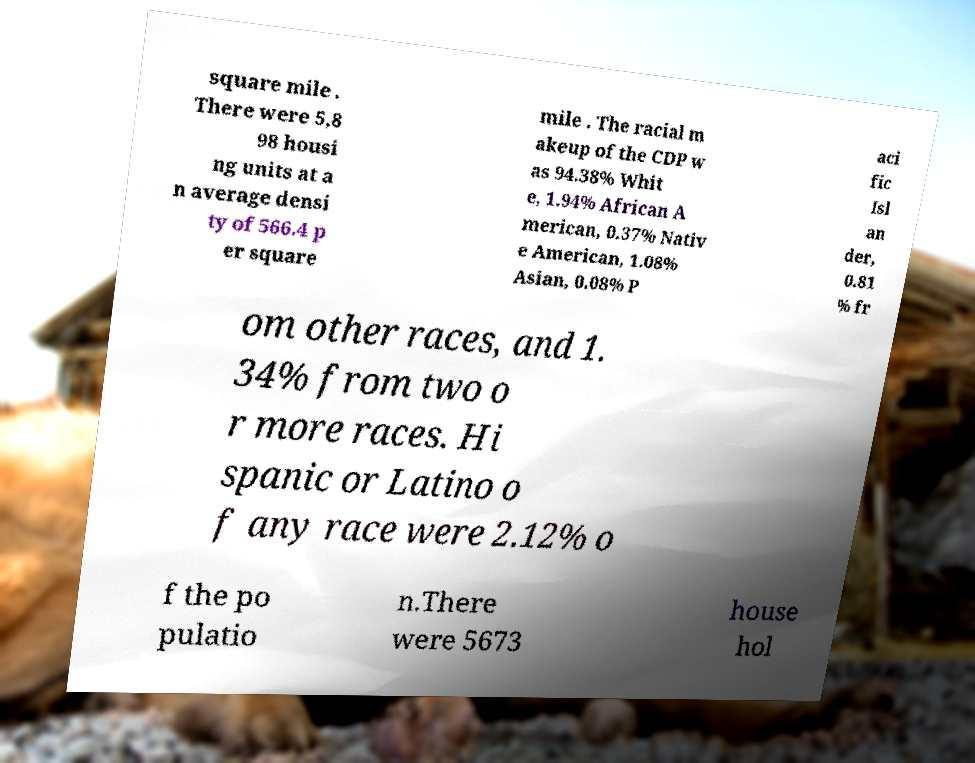Please read and relay the text visible in this image. What does it say? square mile . There were 5,8 98 housi ng units at a n average densi ty of 566.4 p er square mile . The racial m akeup of the CDP w as 94.38% Whit e, 1.94% African A merican, 0.37% Nativ e American, 1.08% Asian, 0.08% P aci fic Isl an der, 0.81 % fr om other races, and 1. 34% from two o r more races. Hi spanic or Latino o f any race were 2.12% o f the po pulatio n.There were 5673 house hol 